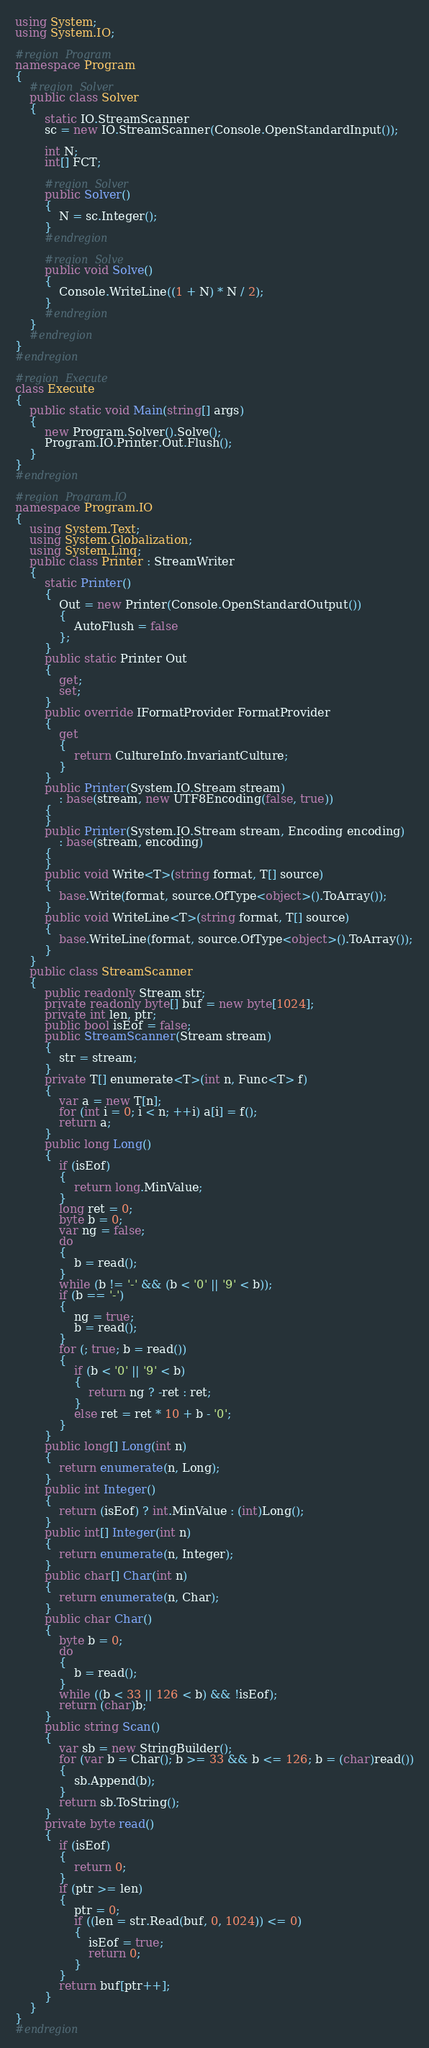<code> <loc_0><loc_0><loc_500><loc_500><_C#_>using System;
using System.IO;

#region Program
namespace Program
{
    #region Solver
    public class Solver
    {
        static IO.StreamScanner
        sc = new IO.StreamScanner(Console.OpenStandardInput());

        int N;
        int[] FCT;

        #region Solver
        public Solver()
        {
            N = sc.Integer();
        }
        #endregion

        #region Solve
        public void Solve()
        {
            Console.WriteLine((1 + N) * N / 2);
        }
        #endregion
    }
    #endregion
}
#endregion

#region Execute
class Execute
{
    public static void Main(string[] args)
    {
        new Program.Solver().Solve();
        Program.IO.Printer.Out.Flush();
    }
}
#endregion

#region Program.IO
namespace Program.IO
{
    using System.Text;
    using System.Globalization;
    using System.Linq;
    public class Printer : StreamWriter
    {
        static Printer()
        {
            Out = new Printer(Console.OpenStandardOutput())
            {
                AutoFlush = false
            };
        }
        public static Printer Out
        {
            get;
            set;
        }
        public override IFormatProvider FormatProvider
        {
            get
            {
                return CultureInfo.InvariantCulture;
            }
        }
        public Printer(System.IO.Stream stream)
            : base(stream, new UTF8Encoding(false, true))
        {
        }
        public Printer(System.IO.Stream stream, Encoding encoding)
            : base(stream, encoding)
        {
        }
        public void Write<T>(string format, T[] source)
        {
            base.Write(format, source.OfType<object>().ToArray());
        }
        public void WriteLine<T>(string format, T[] source)
        {
            base.WriteLine(format, source.OfType<object>().ToArray());
        }
    }
    public class StreamScanner
    {
        public readonly Stream str;
        private readonly byte[] buf = new byte[1024];
        private int len, ptr;
        public bool isEof = false;
        public StreamScanner(Stream stream)
        {
            str = stream;
        }
        private T[] enumerate<T>(int n, Func<T> f)
        {
            var a = new T[n];
            for (int i = 0; i < n; ++i) a[i] = f();
            return a;
        }
        public long Long()
        {
            if (isEof)
            {
                return long.MinValue;
            }
            long ret = 0;
            byte b = 0;
            var ng = false;
            do
            {
                b = read();
            }
            while (b != '-' && (b < '0' || '9' < b));
            if (b == '-')
            {
                ng = true;
                b = read();
            }
            for (; true; b = read())
            {
                if (b < '0' || '9' < b)
                {
                    return ng ? -ret : ret;
                }
                else ret = ret * 10 + b - '0';
            }
        }
        public long[] Long(int n)
        {
            return enumerate(n, Long);
        }
        public int Integer()
        {
            return (isEof) ? int.MinValue : (int)Long();
        }
        public int[] Integer(int n)
        {
            return enumerate(n, Integer);
        }
        public char[] Char(int n)
        {
            return enumerate(n, Char);
        }
        public char Char()
        {
            byte b = 0;
            do
            {
                b = read();
            }
            while ((b < 33 || 126 < b) && !isEof);
            return (char)b;
        }
        public string Scan()
        {
            var sb = new StringBuilder();
            for (var b = Char(); b >= 33 && b <= 126; b = (char)read())
            {
                sb.Append(b);
            }
            return sb.ToString();
        }
        private byte read()
        {
            if (isEof)
            {
                return 0;
            }
            if (ptr >= len)
            {
                ptr = 0;
                if ((len = str.Read(buf, 0, 1024)) <= 0)
                {
                    isEof = true;
                    return 0;
                }
            }
            return buf[ptr++];
        }
    }
}
#endregion
</code> 